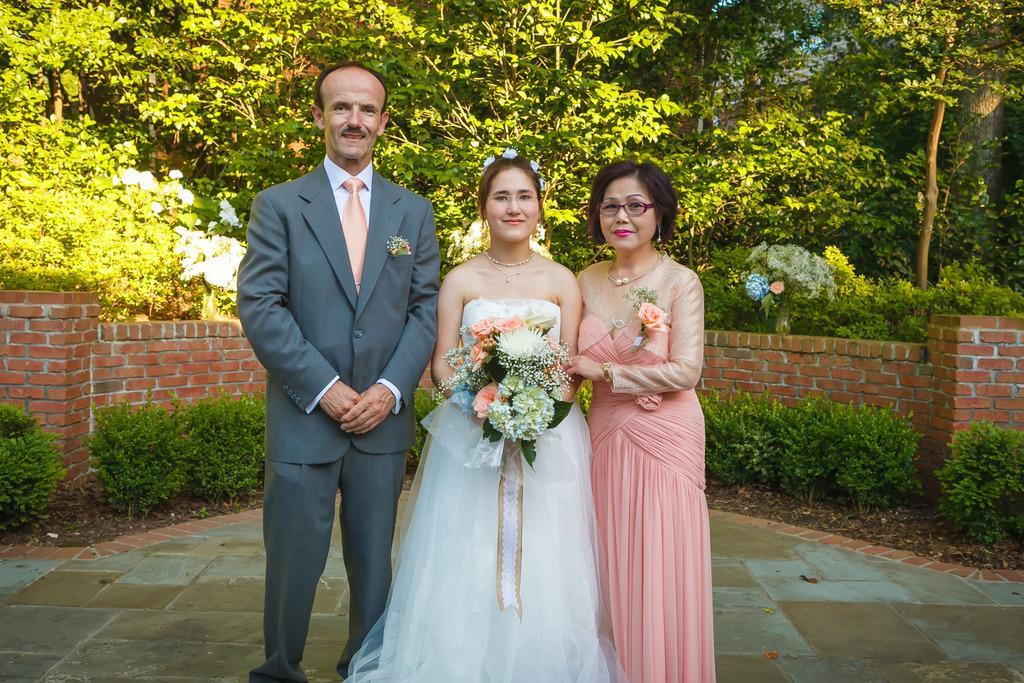Can you describe this image briefly? In this image there are many trees and plants are at the background of the person. There are three persons in the image. 